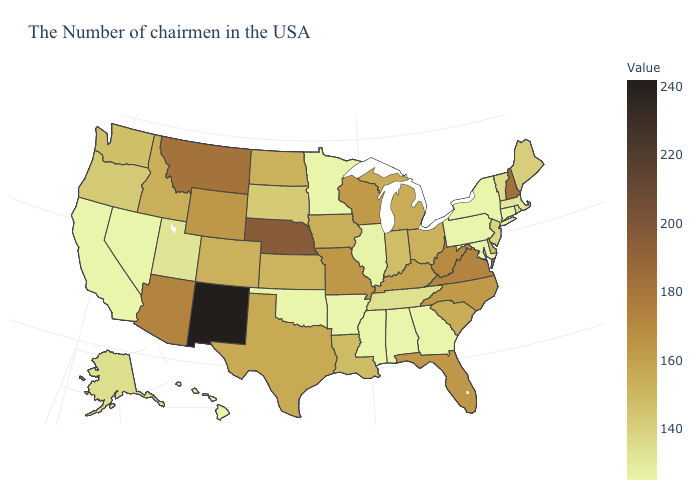Among the states that border Nebraska , which have the lowest value?
Give a very brief answer. South Dakota. Does Ohio have a lower value than New Jersey?
Keep it brief. No. Which states hav the highest value in the MidWest?
Give a very brief answer. Nebraska. Which states have the lowest value in the USA?
Give a very brief answer. Connecticut, New York, Maryland, Pennsylvania, Georgia, Alabama, Mississippi, Arkansas, Minnesota, Oklahoma, Nevada, California, Hawaii. 